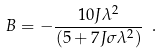Convert formula to latex. <formula><loc_0><loc_0><loc_500><loc_500>B = - \frac { 1 0 J \lambda ^ { 2 } } { \left ( 5 + 7 J \sigma \lambda ^ { 2 } \right ) } \ .</formula> 